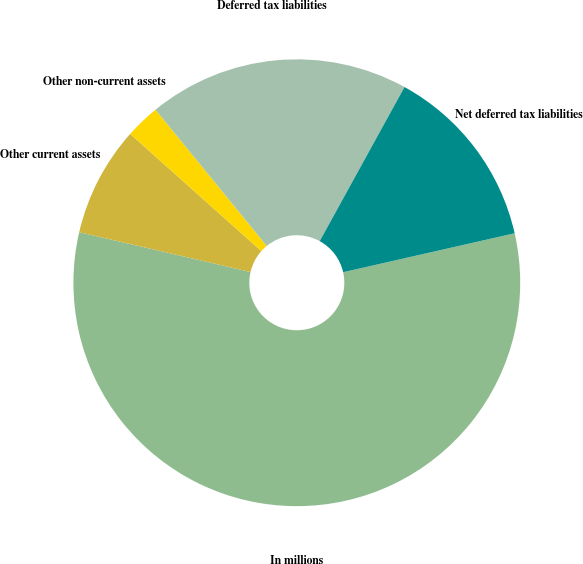Convert chart. <chart><loc_0><loc_0><loc_500><loc_500><pie_chart><fcel>In millions<fcel>Other current assets<fcel>Other non-current assets<fcel>Deferred tax liabilities<fcel>Net deferred tax liabilities<nl><fcel>57.2%<fcel>7.97%<fcel>2.5%<fcel>18.91%<fcel>13.44%<nl></chart> 